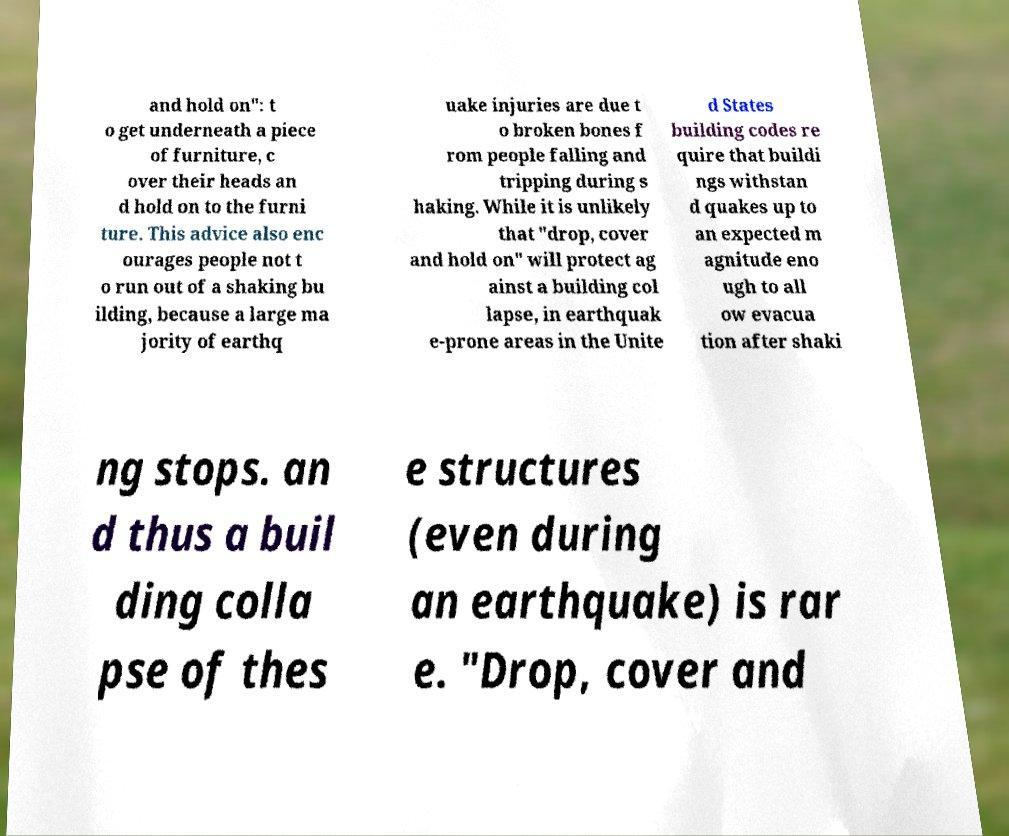Please identify and transcribe the text found in this image. and hold on": t o get underneath a piece of furniture, c over their heads an d hold on to the furni ture. This advice also enc ourages people not t o run out of a shaking bu ilding, because a large ma jority of earthq uake injuries are due t o broken bones f rom people falling and tripping during s haking. While it is unlikely that "drop, cover and hold on" will protect ag ainst a building col lapse, in earthquak e-prone areas in the Unite d States building codes re quire that buildi ngs withstan d quakes up to an expected m agnitude eno ugh to all ow evacua tion after shaki ng stops. an d thus a buil ding colla pse of thes e structures (even during an earthquake) is rar e. "Drop, cover and 